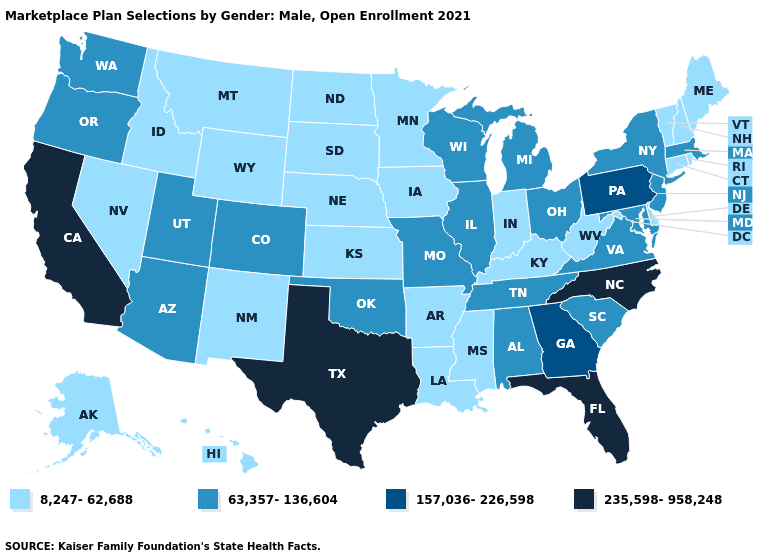What is the value of Montana?
Answer briefly. 8,247-62,688. Does Kentucky have the highest value in the USA?
Be succinct. No. Name the states that have a value in the range 8,247-62,688?
Be succinct. Alaska, Arkansas, Connecticut, Delaware, Hawaii, Idaho, Indiana, Iowa, Kansas, Kentucky, Louisiana, Maine, Minnesota, Mississippi, Montana, Nebraska, Nevada, New Hampshire, New Mexico, North Dakota, Rhode Island, South Dakota, Vermont, West Virginia, Wyoming. Does Louisiana have the lowest value in the South?
Concise answer only. Yes. What is the lowest value in states that border Kansas?
Quick response, please. 8,247-62,688. What is the value of Oklahoma?
Answer briefly. 63,357-136,604. What is the highest value in the USA?
Write a very short answer. 235,598-958,248. What is the highest value in states that border Arizona?
Keep it brief. 235,598-958,248. Does New Hampshire have the highest value in the USA?
Answer briefly. No. Which states have the lowest value in the USA?
Give a very brief answer. Alaska, Arkansas, Connecticut, Delaware, Hawaii, Idaho, Indiana, Iowa, Kansas, Kentucky, Louisiana, Maine, Minnesota, Mississippi, Montana, Nebraska, Nevada, New Hampshire, New Mexico, North Dakota, Rhode Island, South Dakota, Vermont, West Virginia, Wyoming. What is the value of Arkansas?
Answer briefly. 8,247-62,688. What is the value of Pennsylvania?
Short answer required. 157,036-226,598. Does Idaho have a lower value than Texas?
Concise answer only. Yes. Name the states that have a value in the range 8,247-62,688?
Quick response, please. Alaska, Arkansas, Connecticut, Delaware, Hawaii, Idaho, Indiana, Iowa, Kansas, Kentucky, Louisiana, Maine, Minnesota, Mississippi, Montana, Nebraska, Nevada, New Hampshire, New Mexico, North Dakota, Rhode Island, South Dakota, Vermont, West Virginia, Wyoming. 